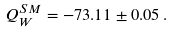<formula> <loc_0><loc_0><loc_500><loc_500>Q _ { W } ^ { S M } = - 7 3 . 1 1 \pm 0 . 0 5 \, .</formula> 